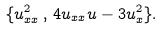Convert formula to latex. <formula><loc_0><loc_0><loc_500><loc_500>\{ u _ { x x } ^ { 2 } \, , \, 4 u _ { x x } u - 3 u _ { x } ^ { 2 } \} .</formula> 